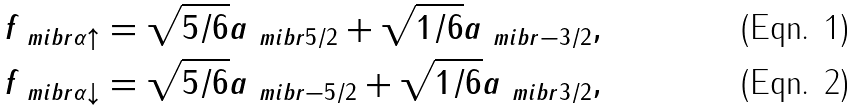Convert formula to latex. <formula><loc_0><loc_0><loc_500><loc_500>f _ { \ m i b { r } \alpha \uparrow } & = \sqrt { 5 / 6 } a _ { \ m i b { r } 5 / 2 } + \sqrt { 1 / 6 } a _ { \ m i b { r } - 3 / 2 } , \\ f _ { \ m i b { r } \alpha \downarrow } & = \sqrt { 5 / 6 } a _ { \ m i b { r } - 5 / 2 } + \sqrt { 1 / 6 } a _ { \ m i b { r } 3 / 2 } ,</formula> 